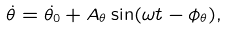Convert formula to latex. <formula><loc_0><loc_0><loc_500><loc_500>\dot { \theta } = \dot { \theta _ { 0 } } + A _ { \theta } \sin ( \omega t - \phi _ { \theta } ) ,</formula> 